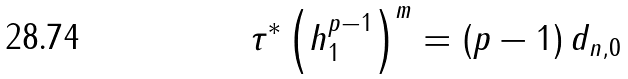Convert formula to latex. <formula><loc_0><loc_0><loc_500><loc_500>\tau ^ { \ast } \left ( h _ { 1 } ^ { p - 1 } \right ) ^ { m } = \left ( p - 1 \right ) d _ { n , 0 }</formula> 